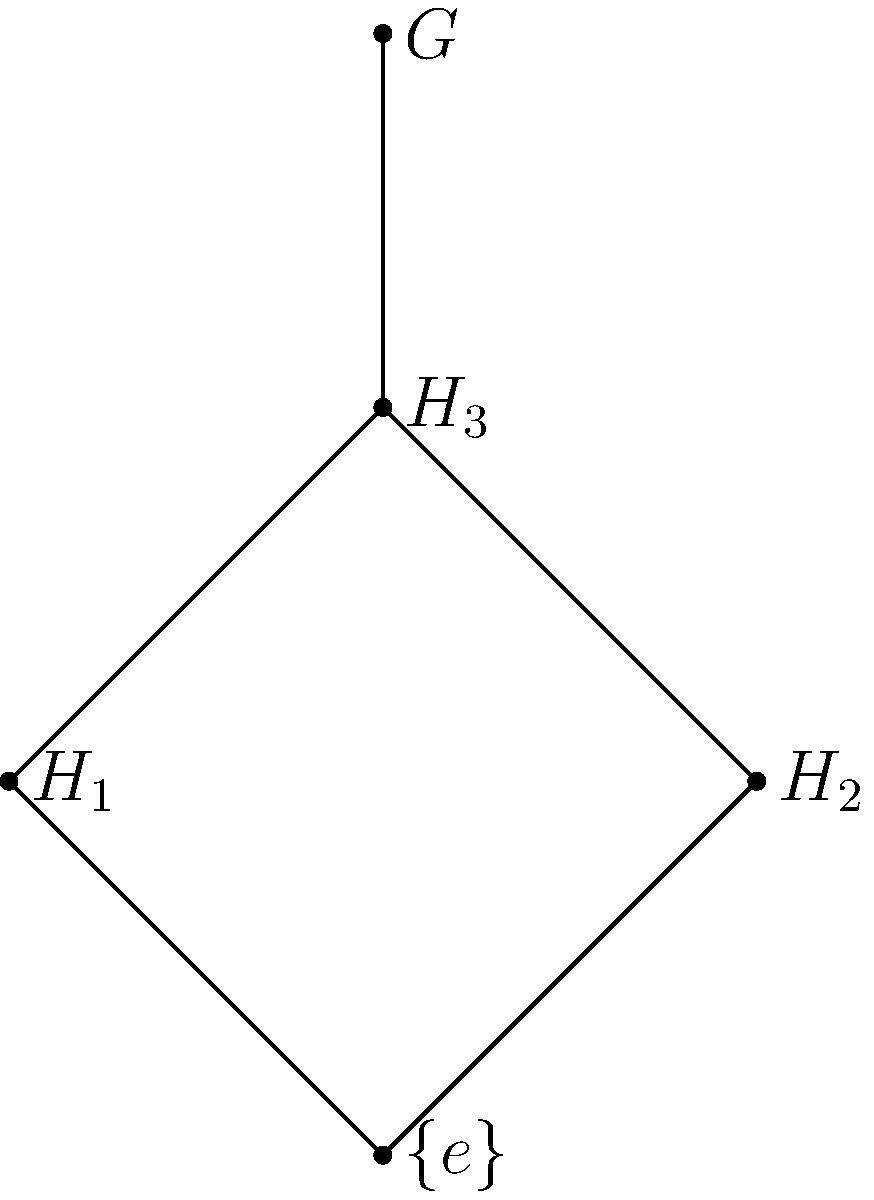Consider the Hasse diagram of the subgroup lattice of a finite group $G$ shown above. If $|G| = 12$, what are the possible orders of the subgroups $H_1$, $H_2$, and $H_3$? To solve this problem, we'll follow these steps:

1) First, recall Lagrange's theorem: the order of a subgroup must divide the order of the group.

2) We're given that $|G| = 12$. The divisors of 12 are 1, 2, 3, 4, 6, and 12.

3) In the Hasse diagram, $\{e\}$ represents the trivial subgroup, which always has order 1.

4) $G$ itself is at the top of the diagram and has order 12.

5) $H_1$ and $H_2$ are directly above $\{e\}$ in the diagram, meaning they are minimal non-trivial subgroups. The smallest possible non-trivial subgroup order is 2.

6) $H_3$ is directly below $G$ and above both $H_1$ and $H_2$. It must have an order that's larger than $H_1$ and $H_2$ but smaller than $G$.

7) Given these constraints, the only possible combination is:
   $|H_1| = |H_2| = 2$
   $|H_3| = 6$

8) This satisfies all conditions: 2 and 6 are divisors of 12, $H_3$ contains both $H_1$ and $H_2$, and $G$ contains $H_3$.

Therefore, the orders of the subgroups are: $|H_1| = 2$, $|H_2| = 2$, and $|H_3| = 6$.
Answer: $|H_1| = 2$, $|H_2| = 2$, $|H_3| = 6$ 